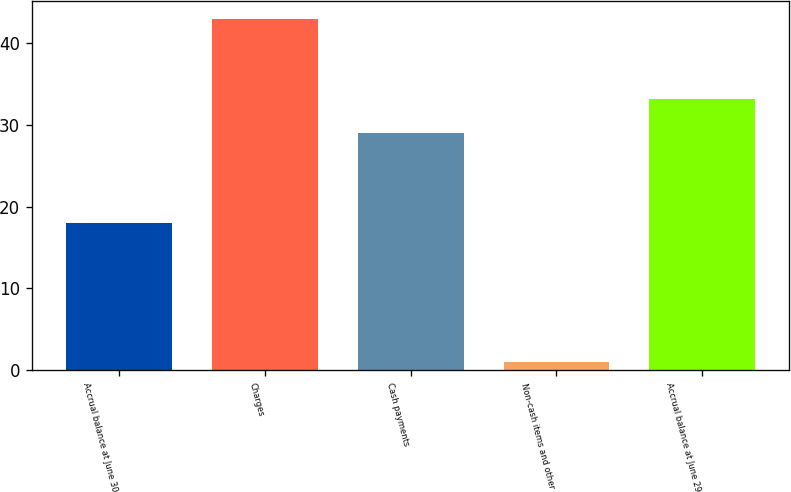Convert chart. <chart><loc_0><loc_0><loc_500><loc_500><bar_chart><fcel>Accrual balance at June 30<fcel>Charges<fcel>Cash payments<fcel>Non-cash items and other<fcel>Accrual balance at June 29<nl><fcel>18<fcel>43<fcel>29<fcel>1<fcel>33.2<nl></chart> 